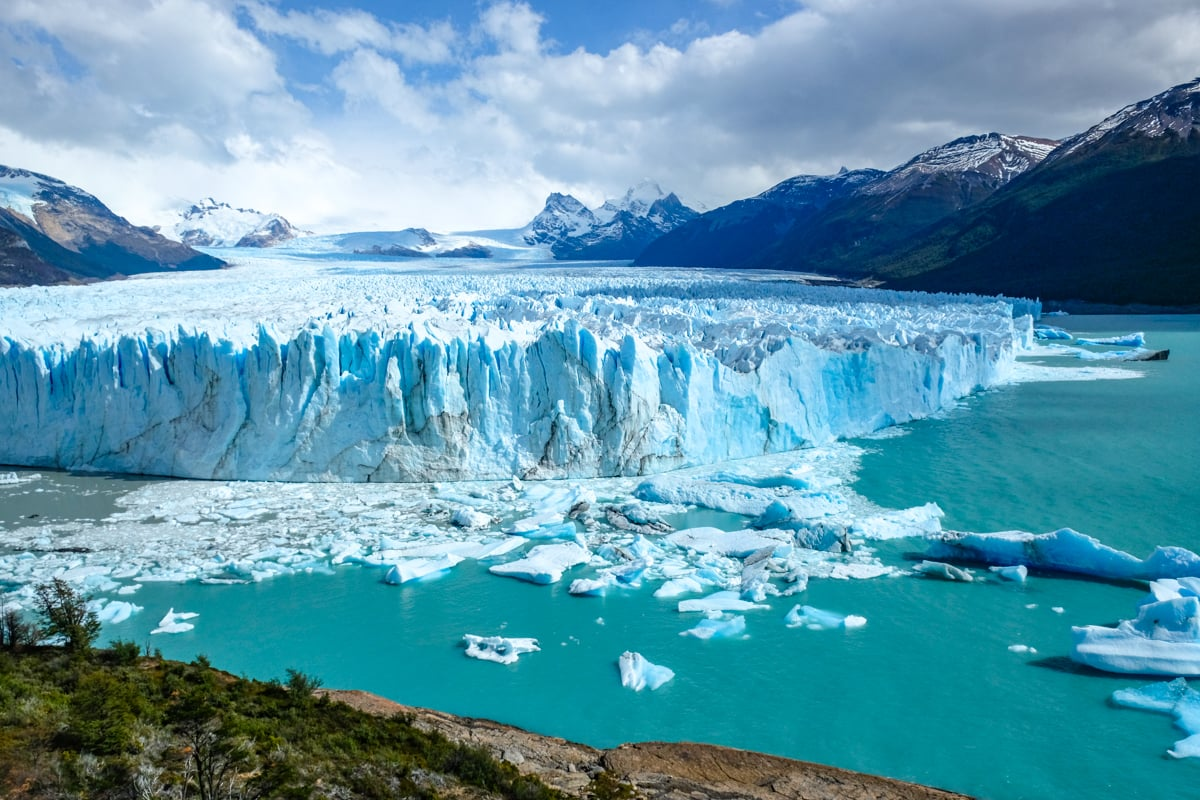Analyze the image in a comprehensive and detailed manner. The image presents the majestic Perito Moreno Glacier, a natural wonder located in the Los Glaciares National Park near El Calafate, Argentina. This towering ice formation is renowned for its dynamic changes and accessibility. Ahead, the glacier's face, with its spectacular shades of blue and white, rises imposingly above the lake's surface, hinting at the immense pressure and gradual movement that sculpted its facade. Turquoise waters of Lago Argentino are peppered with floating icebergs that have calved from the glacier, a testament to its ever-evolving nature. The backdrop of rugged mountains and clear skies enhances the glacier’s natural beauty and speaks to the environmental importance of this UNESCO World Heritage Site, which serves as a critical freshwater reservoir and a barometer for climate change effects. 